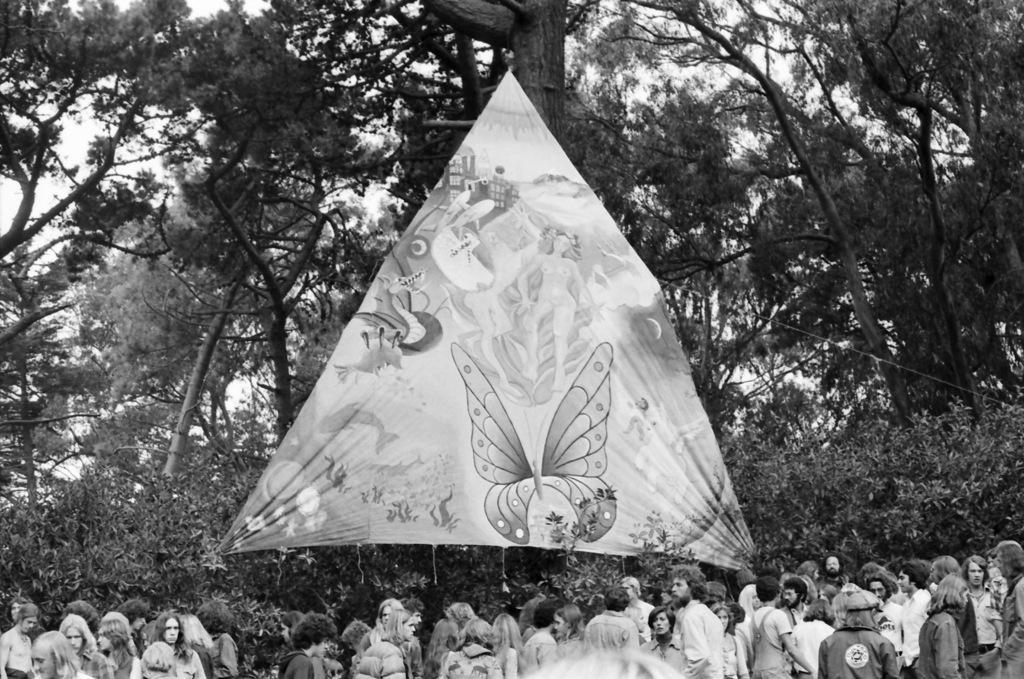How would you summarize this image in a sentence or two? On the bottom we can see group of persons who are standing near to the plants. Here we can see a cloth which is hanged to the trees and plants. On the cloth we can see butterflies, woman and other things in the picture. On the background we can see many trees. Here it's a sky. 